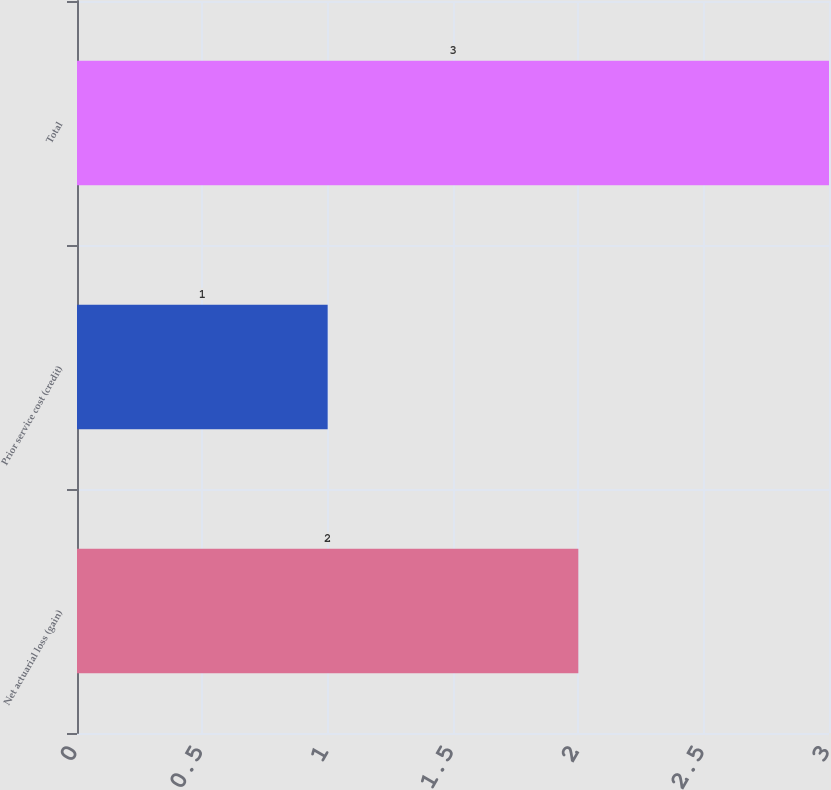Convert chart to OTSL. <chart><loc_0><loc_0><loc_500><loc_500><bar_chart><fcel>Net actuarial loss (gain)<fcel>Prior service cost (credit)<fcel>Total<nl><fcel>2<fcel>1<fcel>3<nl></chart> 